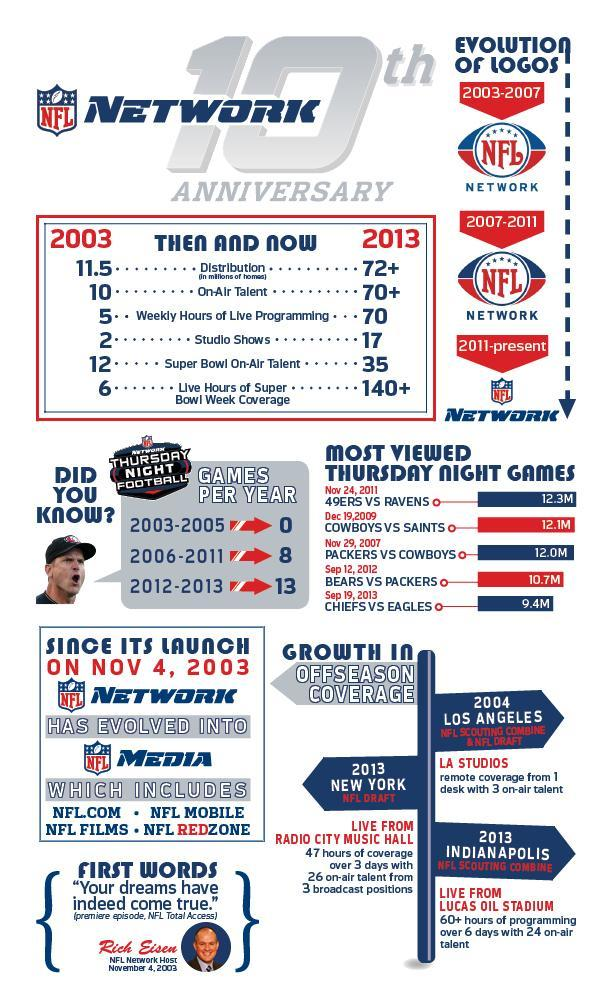Which year had the second most viewed Thursday night game, 2003, 2005, or 2009?
Answer the question with a short phrase. 2009 